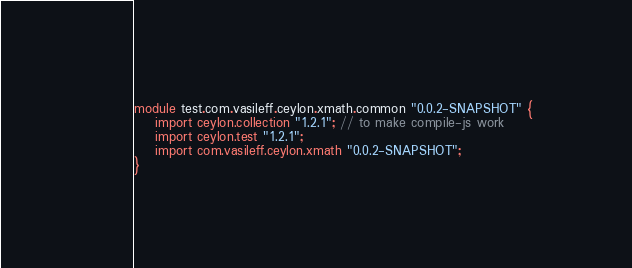Convert code to text. <code><loc_0><loc_0><loc_500><loc_500><_Ceylon_>module test.com.vasileff.ceylon.xmath.common "0.0.2-SNAPSHOT" {
    import ceylon.collection "1.2.1"; // to make compile-js work
    import ceylon.test "1.2.1";
    import com.vasileff.ceylon.xmath "0.0.2-SNAPSHOT";
}
</code> 